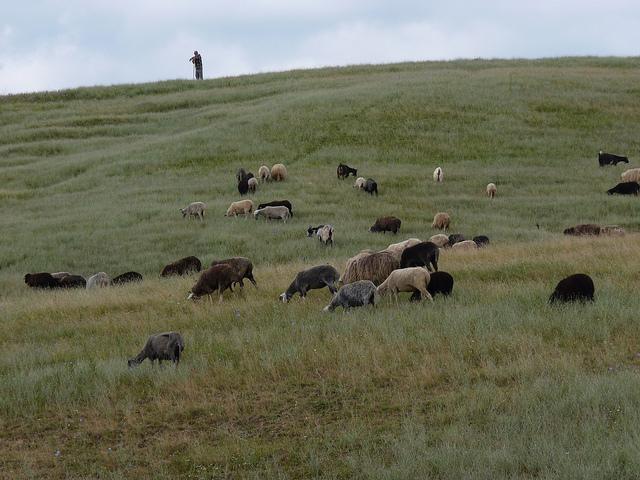Is this a cow farm?
Keep it brief. Yes. What are the animals doing?
Short answer required. Grazing. What breed of livestock is shown?
Concise answer only. Sheep. How many black sheep are there?
Be succinct. 10. What game would you play when you saw this as a child?
Give a very brief answer. Tag. Where is the human?
Quick response, please. On top of hill. Is this a prairie?
Give a very brief answer. Yes. Is there a village in the background?
Keep it brief. No. 